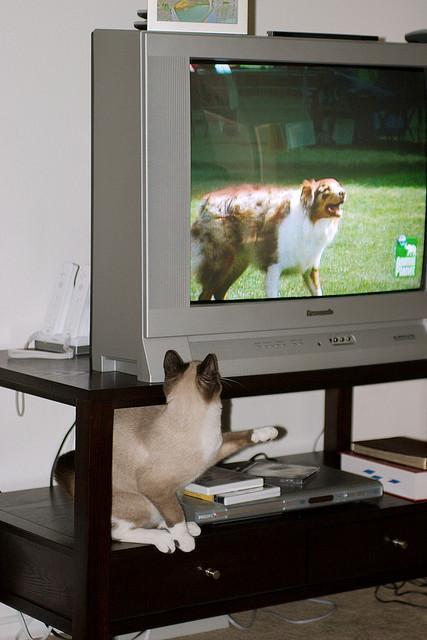How many dogs are visible?
Give a very brief answer. 1. 